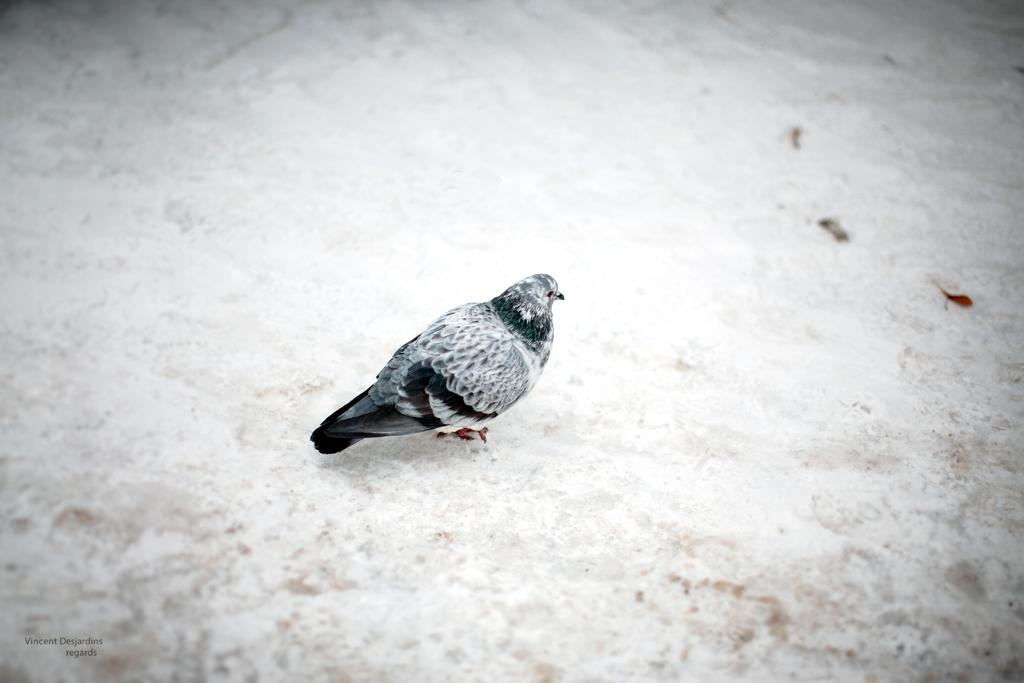What is the main subject in the center of the image? There is a bird in the center of the image. What type of iron is the bird using to embark on a voyage in the image? There is no iron or voyage present in the image; it features a bird in the center. 